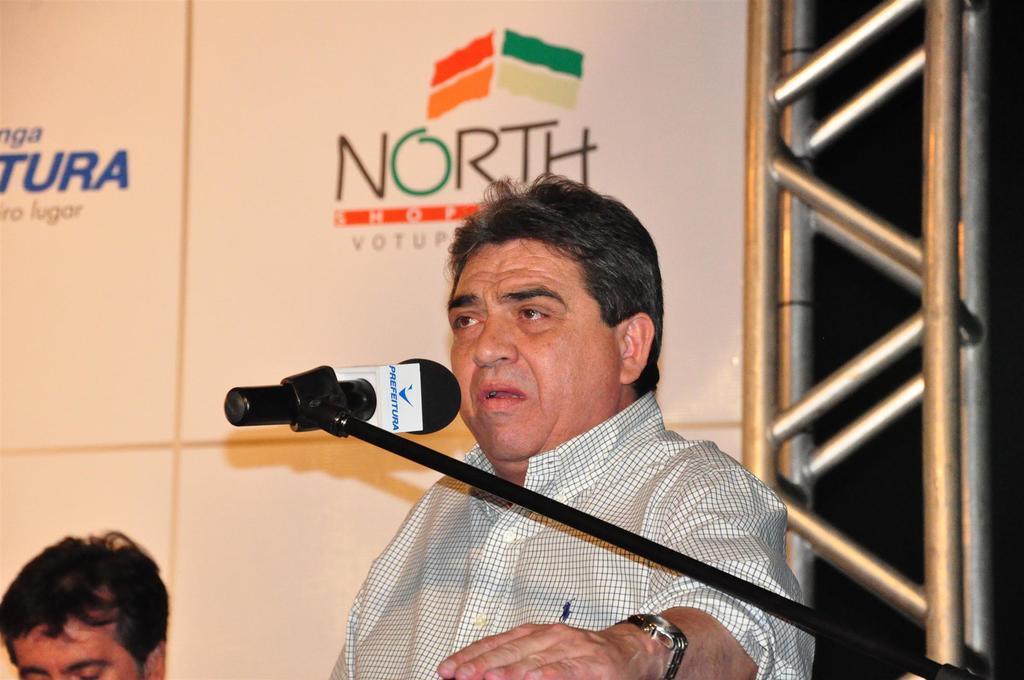Could you give a brief overview of what you see in this image? In the center of the image there is a person talking in mic. To the left side of the image there is persons head. 